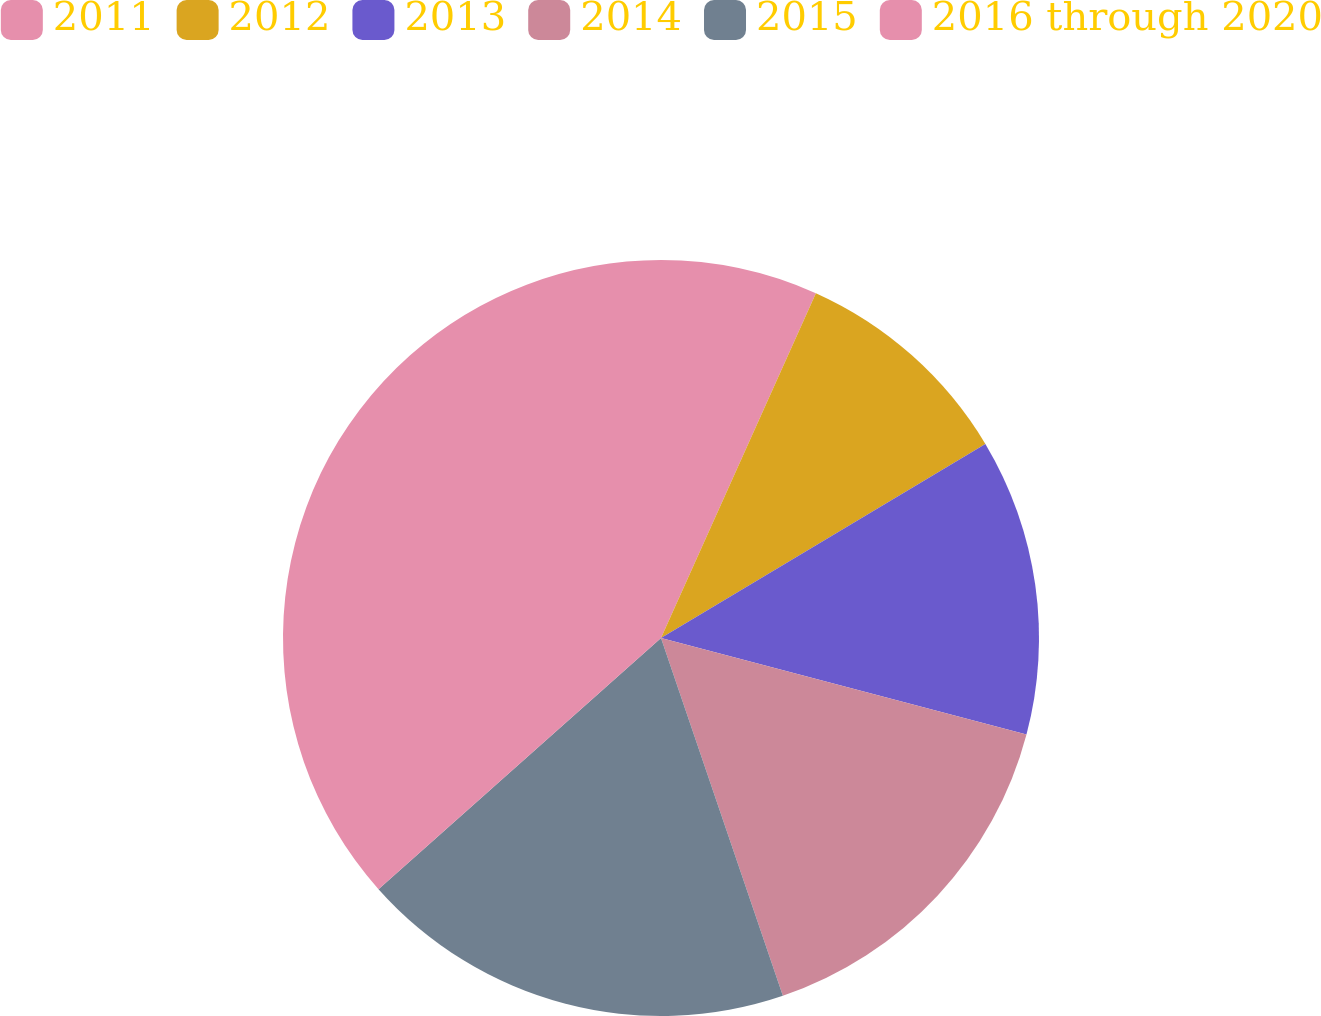Convert chart to OTSL. <chart><loc_0><loc_0><loc_500><loc_500><pie_chart><fcel>2011<fcel>2012<fcel>2013<fcel>2014<fcel>2015<fcel>2016 through 2020<nl><fcel>6.72%<fcel>9.7%<fcel>12.69%<fcel>15.67%<fcel>18.66%<fcel>36.57%<nl></chart> 